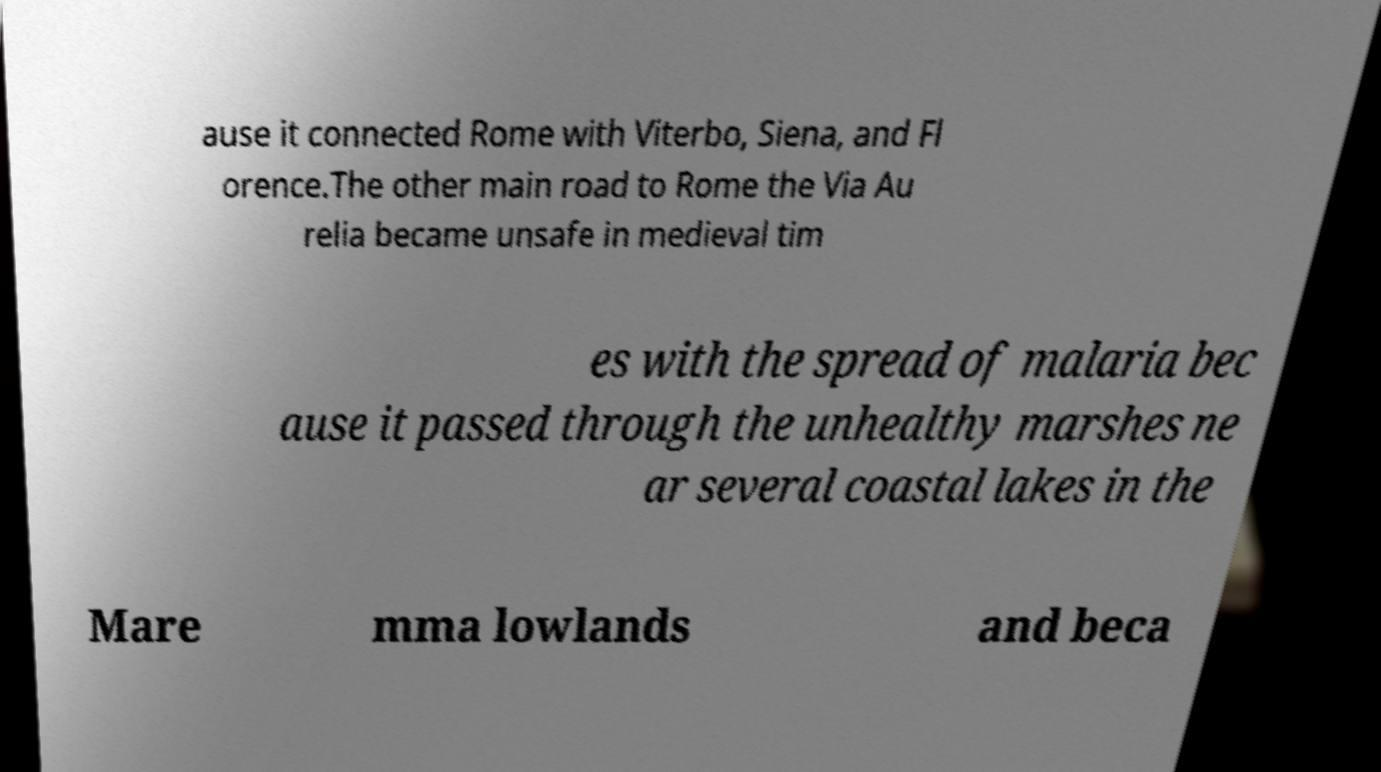Could you extract and type out the text from this image? ause it connected Rome with Viterbo, Siena, and Fl orence.The other main road to Rome the Via Au relia became unsafe in medieval tim es with the spread of malaria bec ause it passed through the unhealthy marshes ne ar several coastal lakes in the Mare mma lowlands and beca 